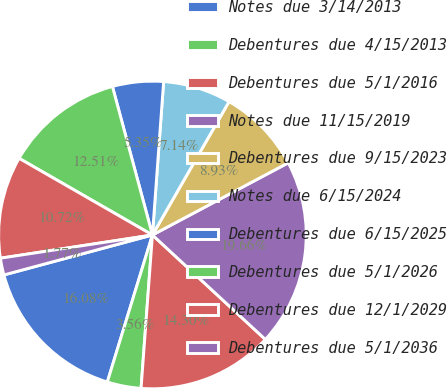Convert chart to OTSL. <chart><loc_0><loc_0><loc_500><loc_500><pie_chart><fcel>Notes due 3/14/2013<fcel>Debentures due 4/15/2013<fcel>Debentures due 5/1/2016<fcel>Notes due 11/15/2019<fcel>Debentures due 9/15/2023<fcel>Notes due 6/15/2024<fcel>Debentures due 6/15/2025<fcel>Debentures due 5/1/2026<fcel>Debentures due 12/1/2029<fcel>Debentures due 5/1/2036<nl><fcel>16.08%<fcel>3.56%<fcel>14.3%<fcel>19.66%<fcel>8.93%<fcel>7.14%<fcel>5.35%<fcel>12.51%<fcel>10.72%<fcel>1.77%<nl></chart> 